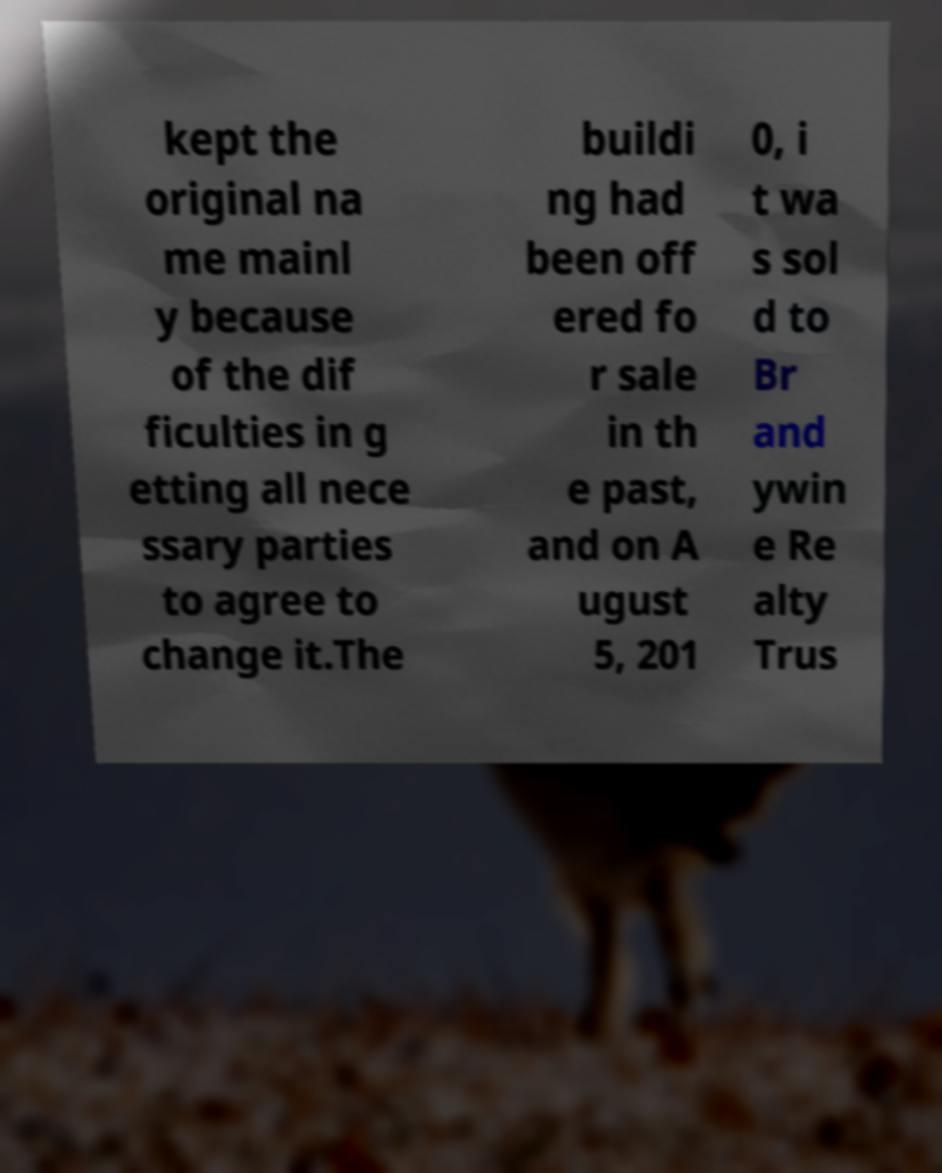Can you read and provide the text displayed in the image?This photo seems to have some interesting text. Can you extract and type it out for me? kept the original na me mainl y because of the dif ficulties in g etting all nece ssary parties to agree to change it.The buildi ng had been off ered fo r sale in th e past, and on A ugust 5, 201 0, i t wa s sol d to Br and ywin e Re alty Trus 